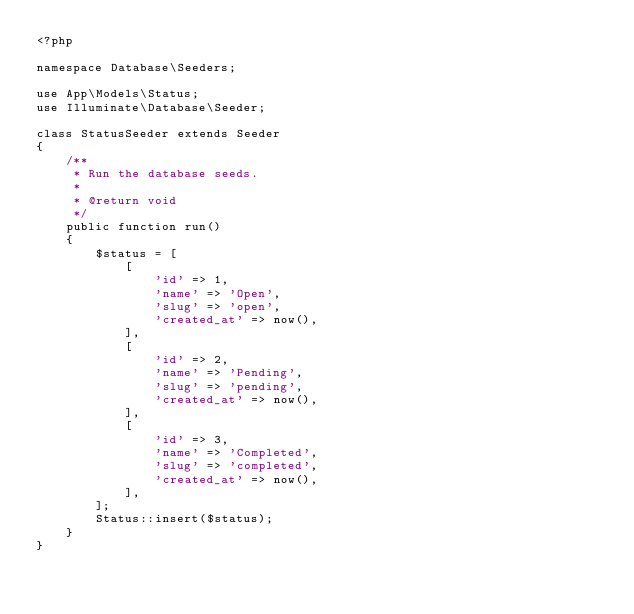Convert code to text. <code><loc_0><loc_0><loc_500><loc_500><_PHP_><?php

namespace Database\Seeders;

use App\Models\Status;
use Illuminate\Database\Seeder;

class StatusSeeder extends Seeder
{
    /**
     * Run the database seeds.
     *
     * @return void
     */
    public function run()
    {
        $status = [
            [
                'id' => 1,
                'name' => 'Open',
                'slug' => 'open',
                'created_at' => now(),
            ],
            [
                'id' => 2,
                'name' => 'Pending',
                'slug' => 'pending',
                'created_at' => now(),
            ],
            [
                'id' => 3,
                'name' => 'Completed',
                'slug' => 'completed',
                'created_at' => now(),
            ],
        ];
        Status::insert($status);
    }
}
</code> 